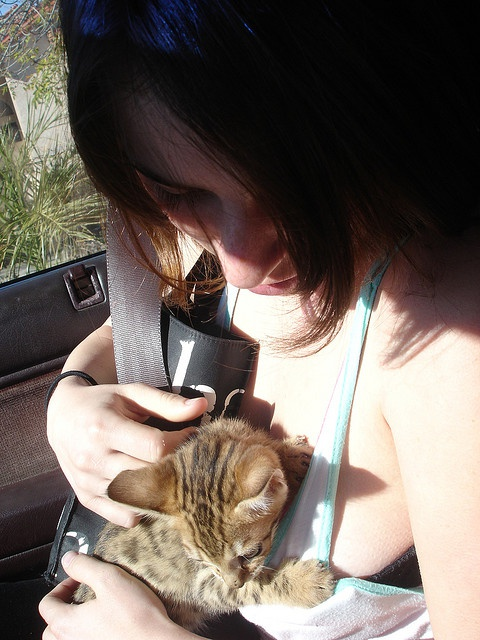Describe the objects in this image and their specific colors. I can see people in black, gray, ivory, and maroon tones and cat in gray and tan tones in this image. 